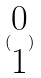<formula> <loc_0><loc_0><loc_500><loc_500>( \begin{matrix} 0 \\ 1 \end{matrix} )</formula> 